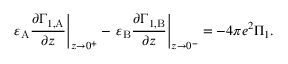<formula> <loc_0><loc_0><loc_500><loc_500>\varepsilon _ { A } \frac { \partial \Gamma _ { 1 , A } } { \partial z } \right | _ { z \to 0 ^ { + } } - \varepsilon _ { B } \frac { \partial \Gamma _ { 1 , B } } { \partial z } \right | _ { z \to 0 ^ { - } } = - 4 \pi e ^ { 2 } \Pi _ { 1 } .</formula> 